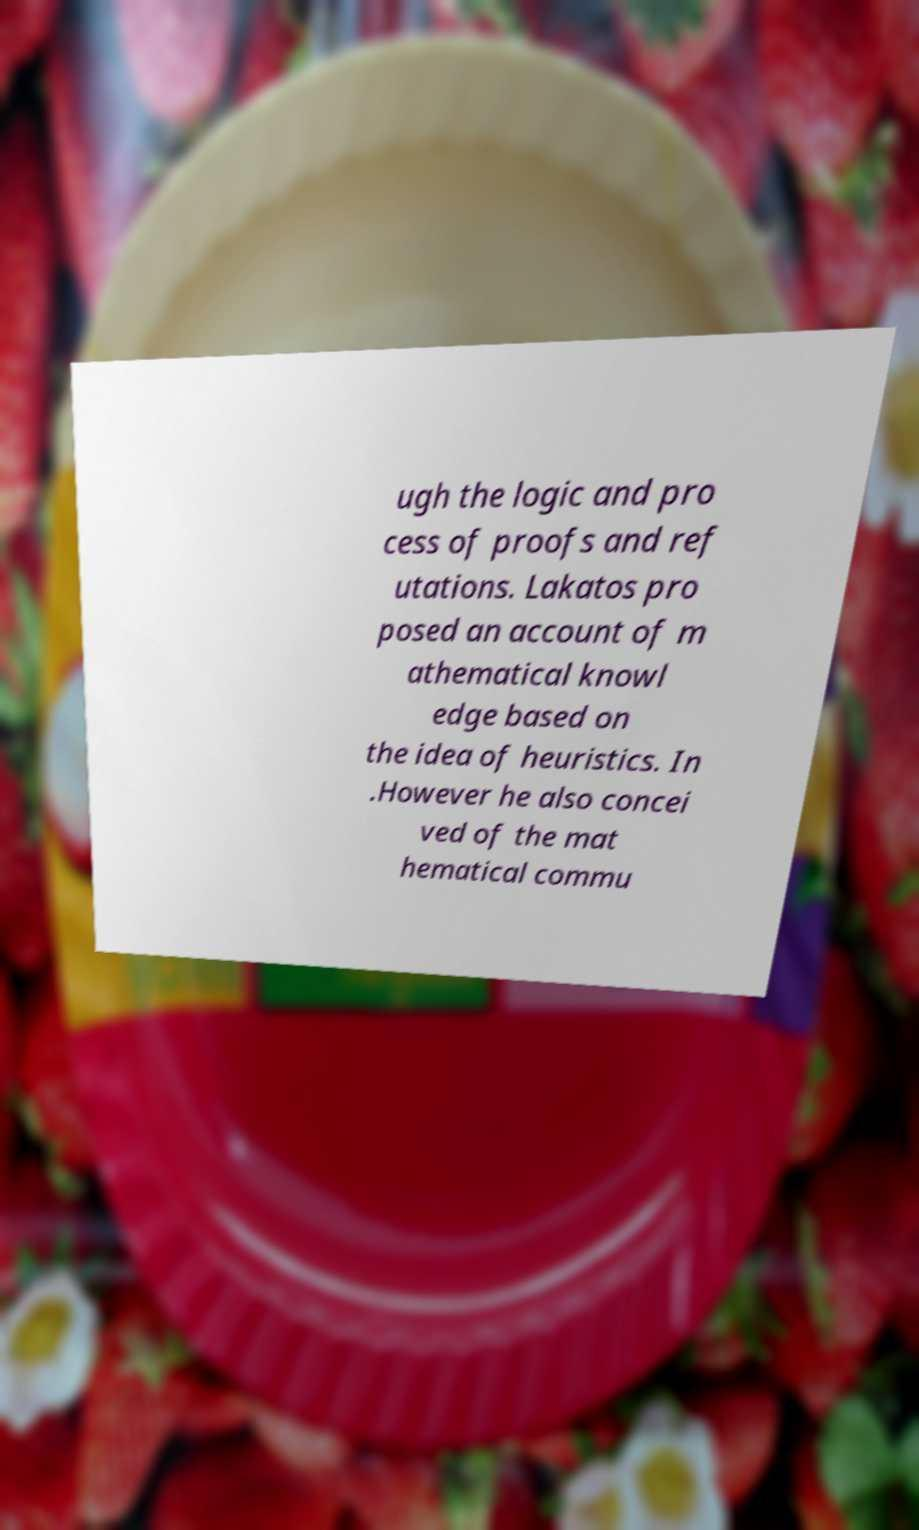Could you assist in decoding the text presented in this image and type it out clearly? ugh the logic and pro cess of proofs and ref utations. Lakatos pro posed an account of m athematical knowl edge based on the idea of heuristics. In .However he also concei ved of the mat hematical commu 